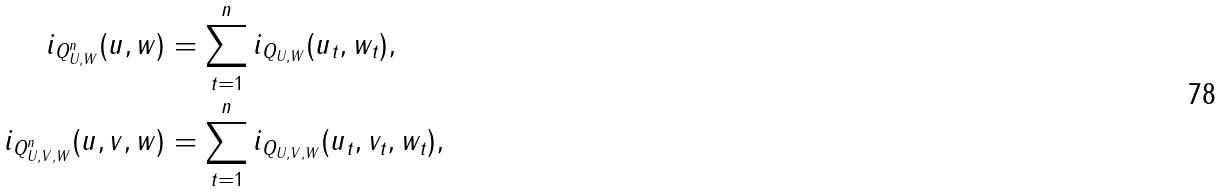<formula> <loc_0><loc_0><loc_500><loc_500>i _ { Q ^ { n } _ { U , W } } ( u , w ) & = \sum _ { t = 1 } ^ { n } i _ { Q _ { U , W } } ( u _ { t } , w _ { t } ) , \\ i _ { Q ^ { n } _ { U , V , W } } ( u , v , w ) & = \sum _ { t = 1 } ^ { n } i _ { Q _ { U , V , W } } ( u _ { t } , v _ { t } , w _ { t } ) ,</formula> 